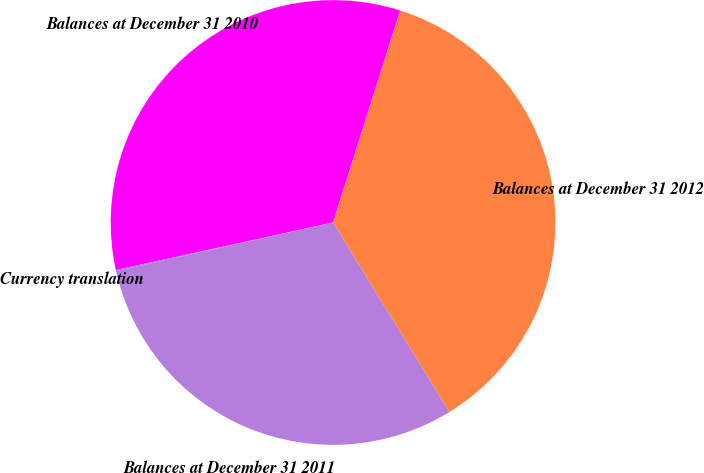<chart> <loc_0><loc_0><loc_500><loc_500><pie_chart><fcel>Balances at December 31 2010<fcel>Currency translation<fcel>Balances at December 31 2011<fcel>Balances at December 31 2012<nl><fcel>33.31%<fcel>0.07%<fcel>30.27%<fcel>36.35%<nl></chart> 